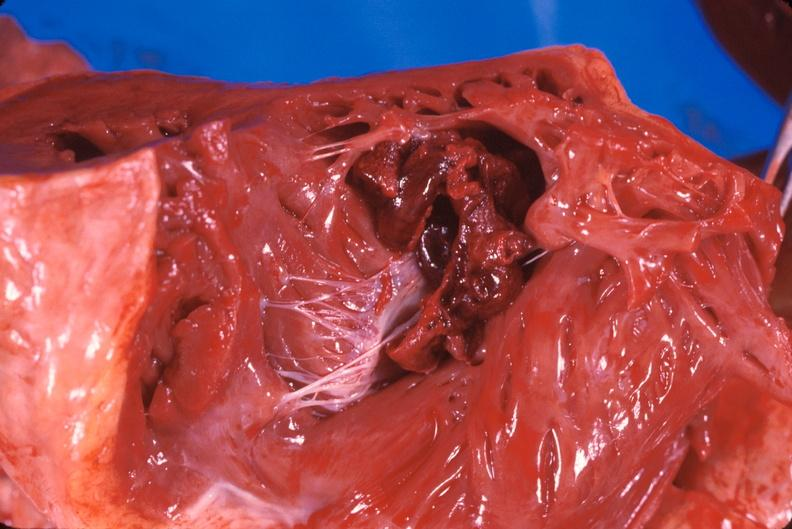s this image shows of smooth muscle cell with lipid in sarcoplasm and lipid present?
Answer the question using a single word or phrase. No 